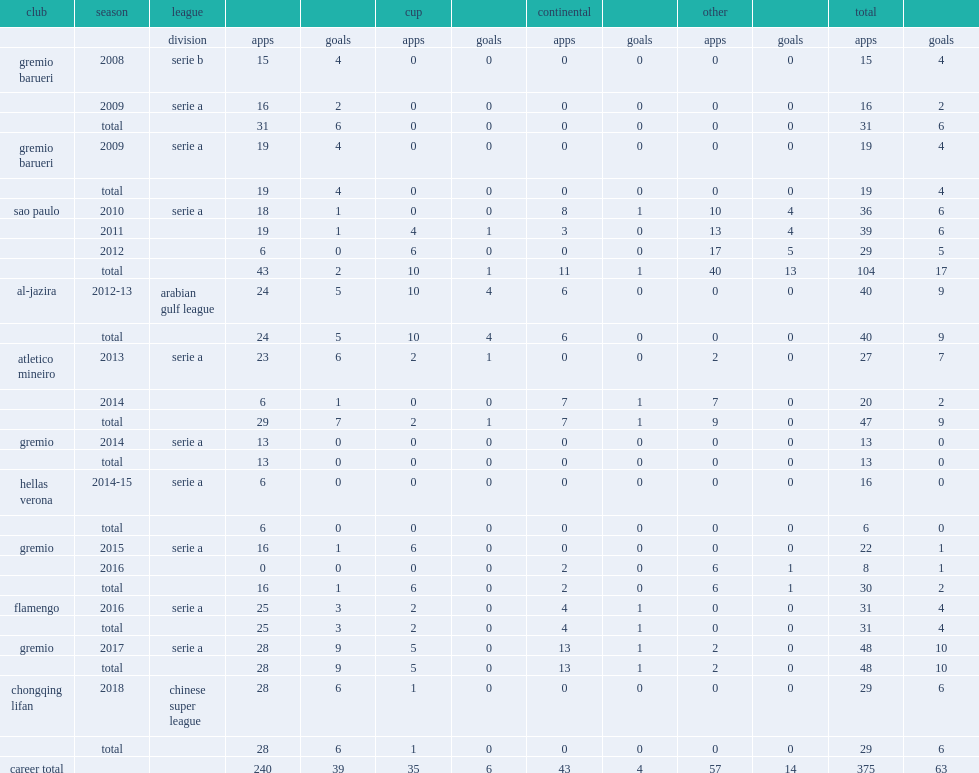Which league did fernandinho join side chongqing lifan in 2018? Chinese super league. 